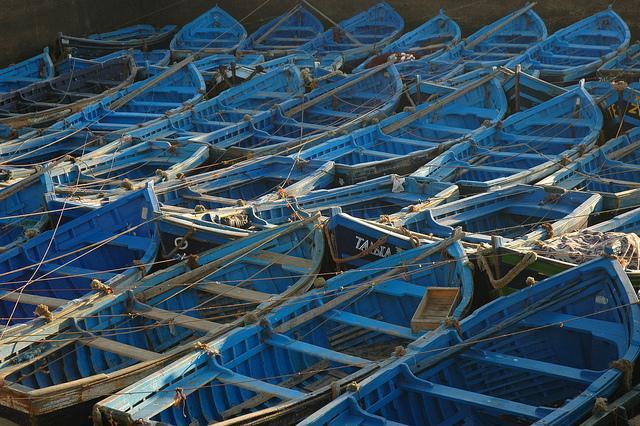How many boats are there?
Give a very brief answer. 14. 